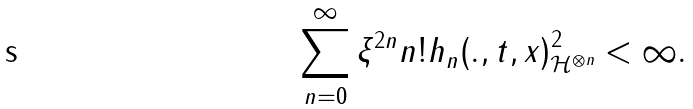Convert formula to latex. <formula><loc_0><loc_0><loc_500><loc_500>\sum _ { n = 0 } ^ { \infty } \xi ^ { 2 n } n ! { \| h _ { n } ( . , t , x ) \| } _ { \mathcal { H } ^ { \otimes n } } ^ { 2 } < \infty .</formula> 